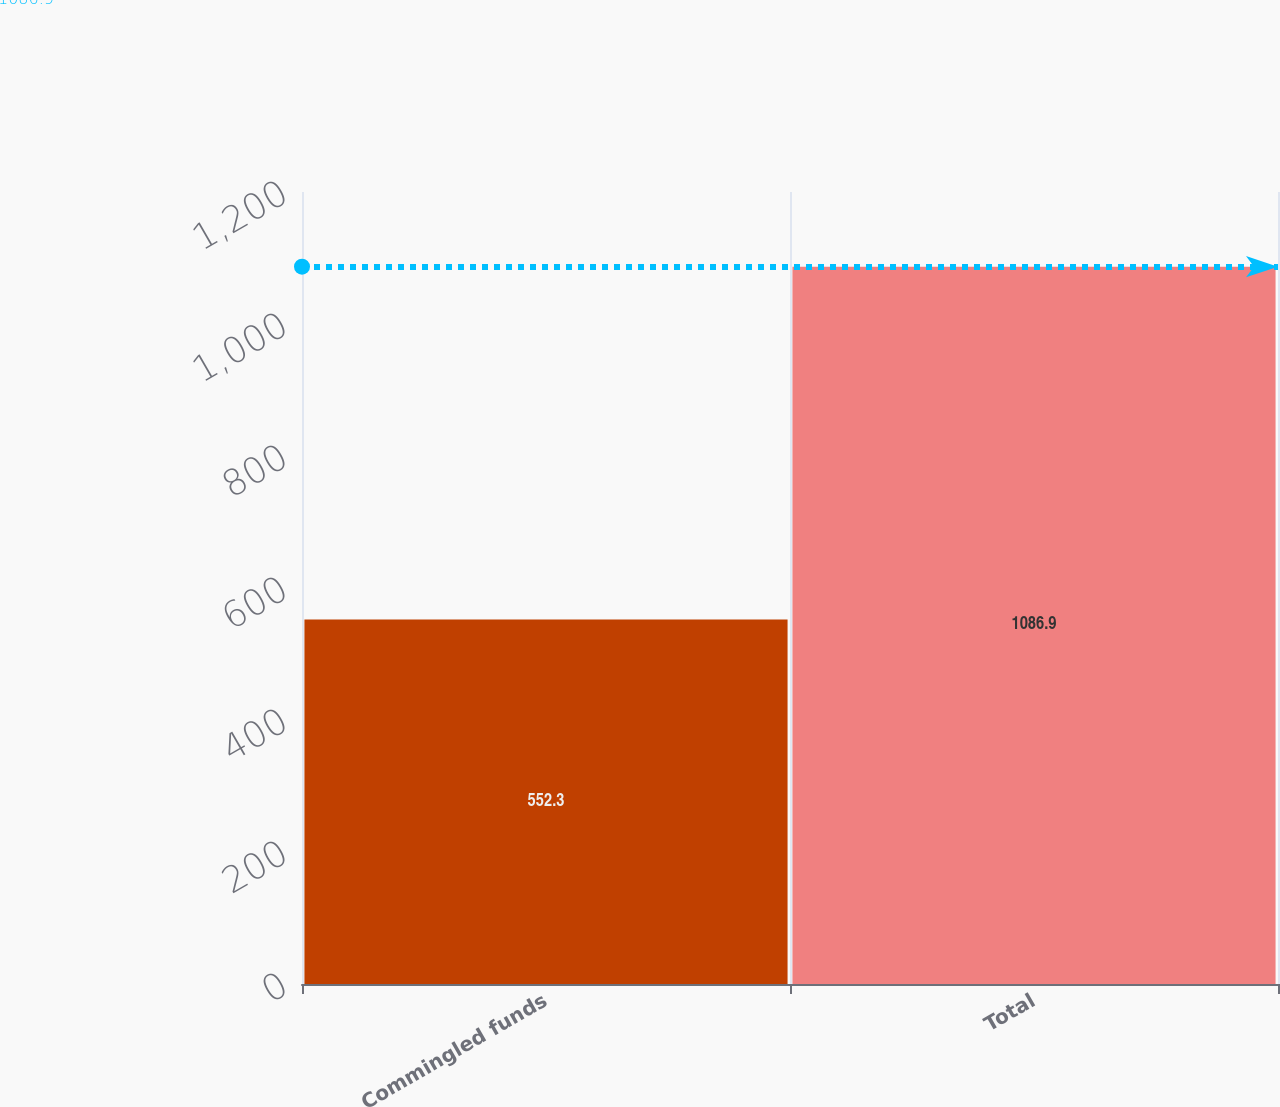Convert chart to OTSL. <chart><loc_0><loc_0><loc_500><loc_500><bar_chart><fcel>Commingled funds<fcel>Total<nl><fcel>552.3<fcel>1086.9<nl></chart> 